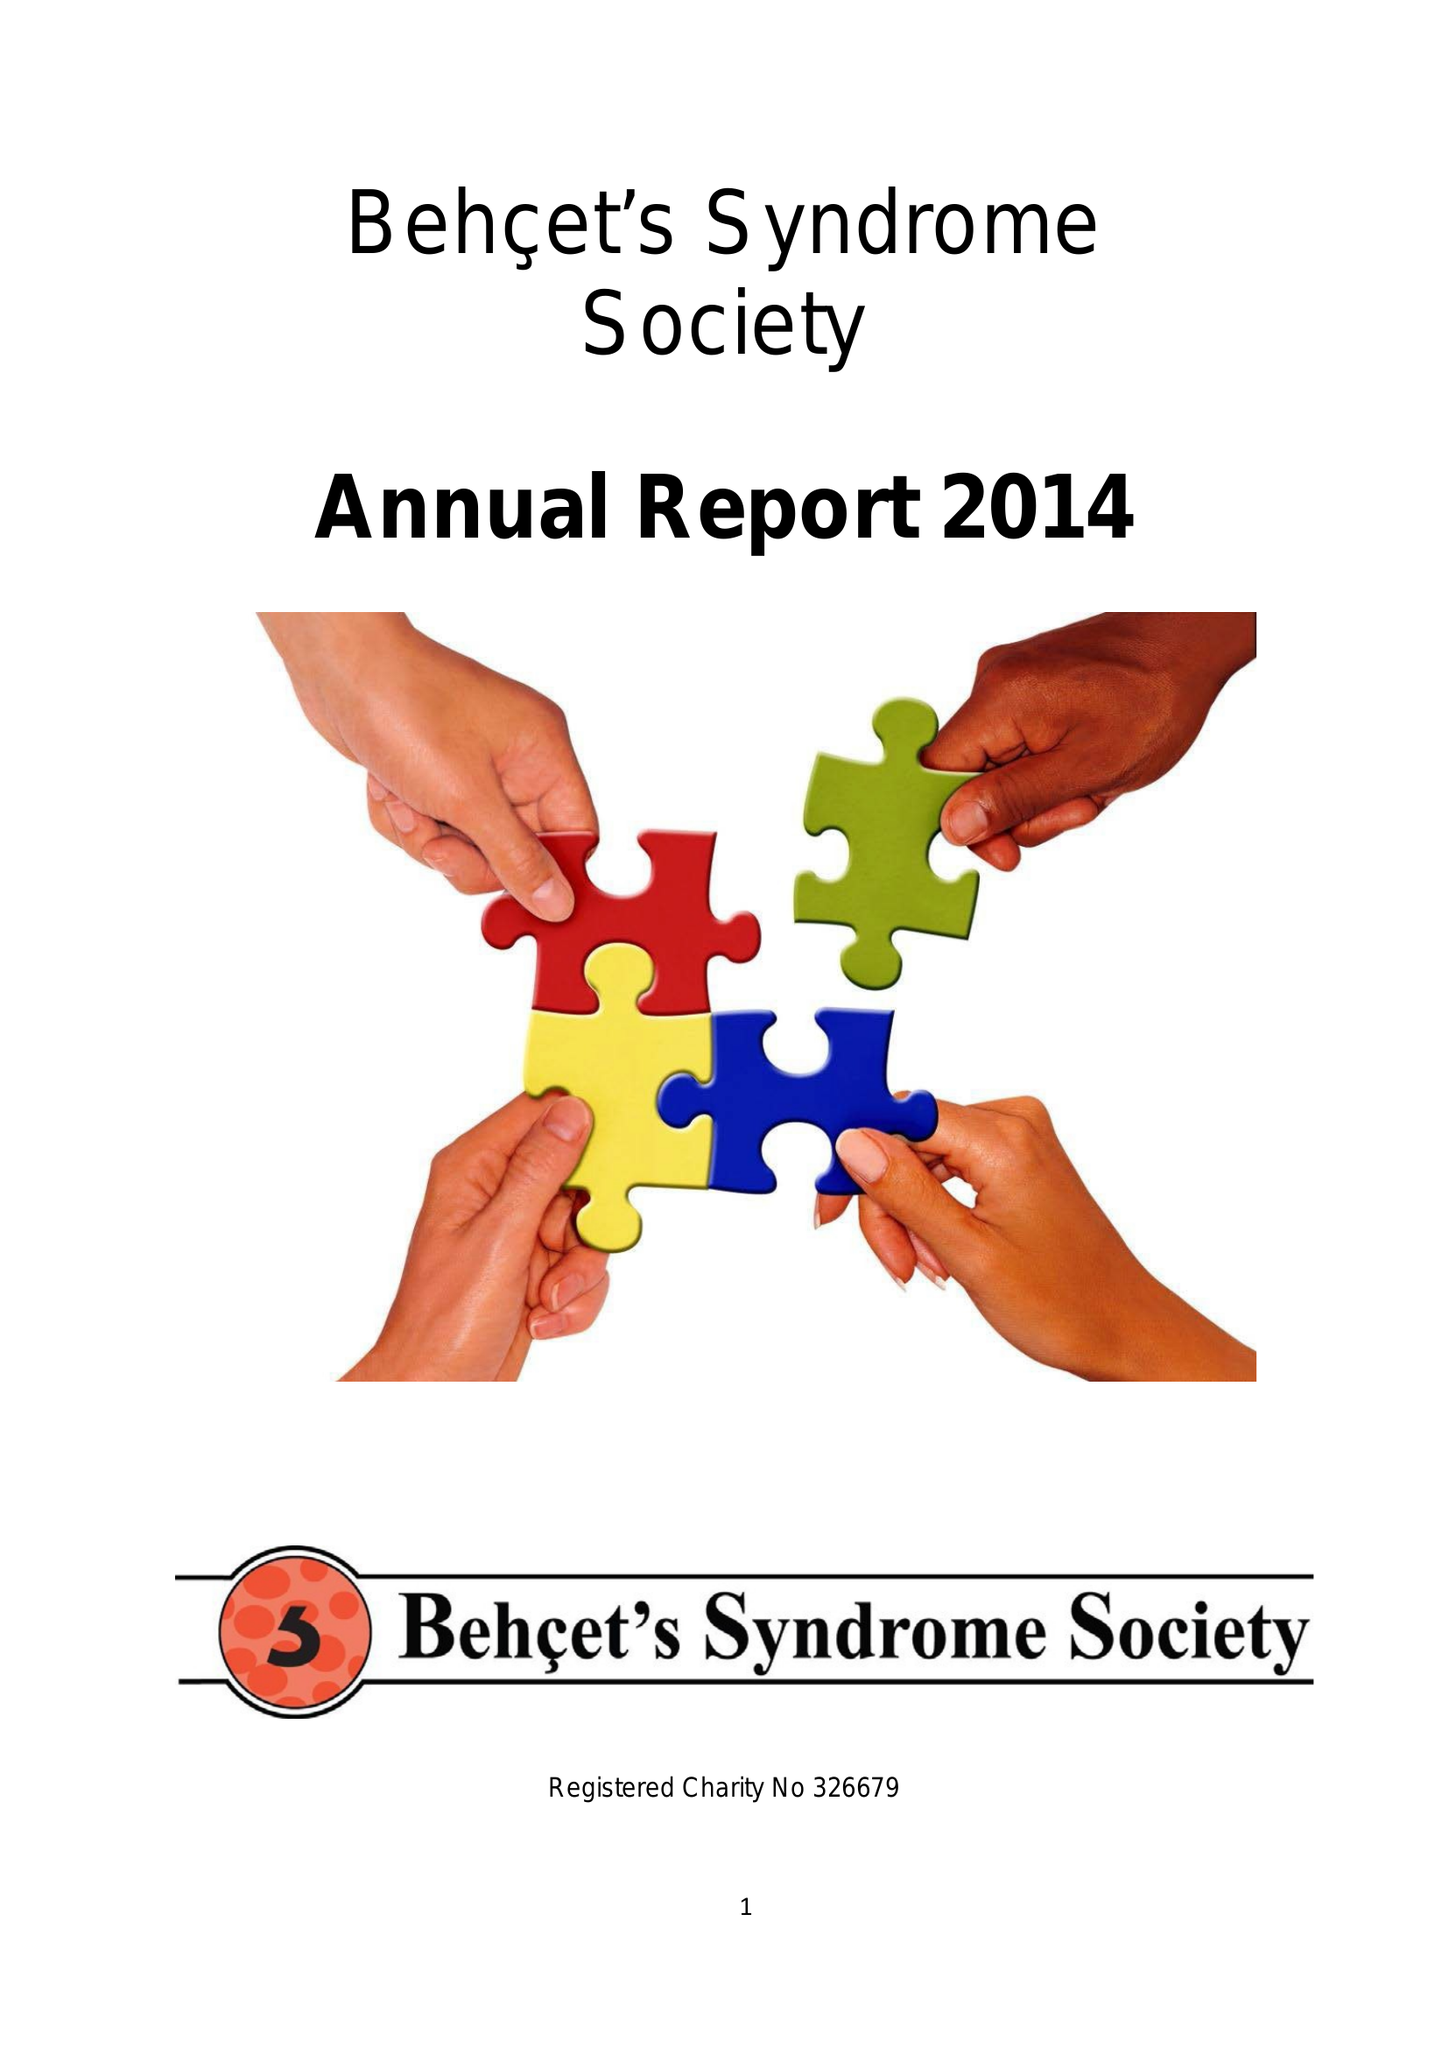What is the value for the charity_number?
Answer the question using a single word or phrase. 326679 